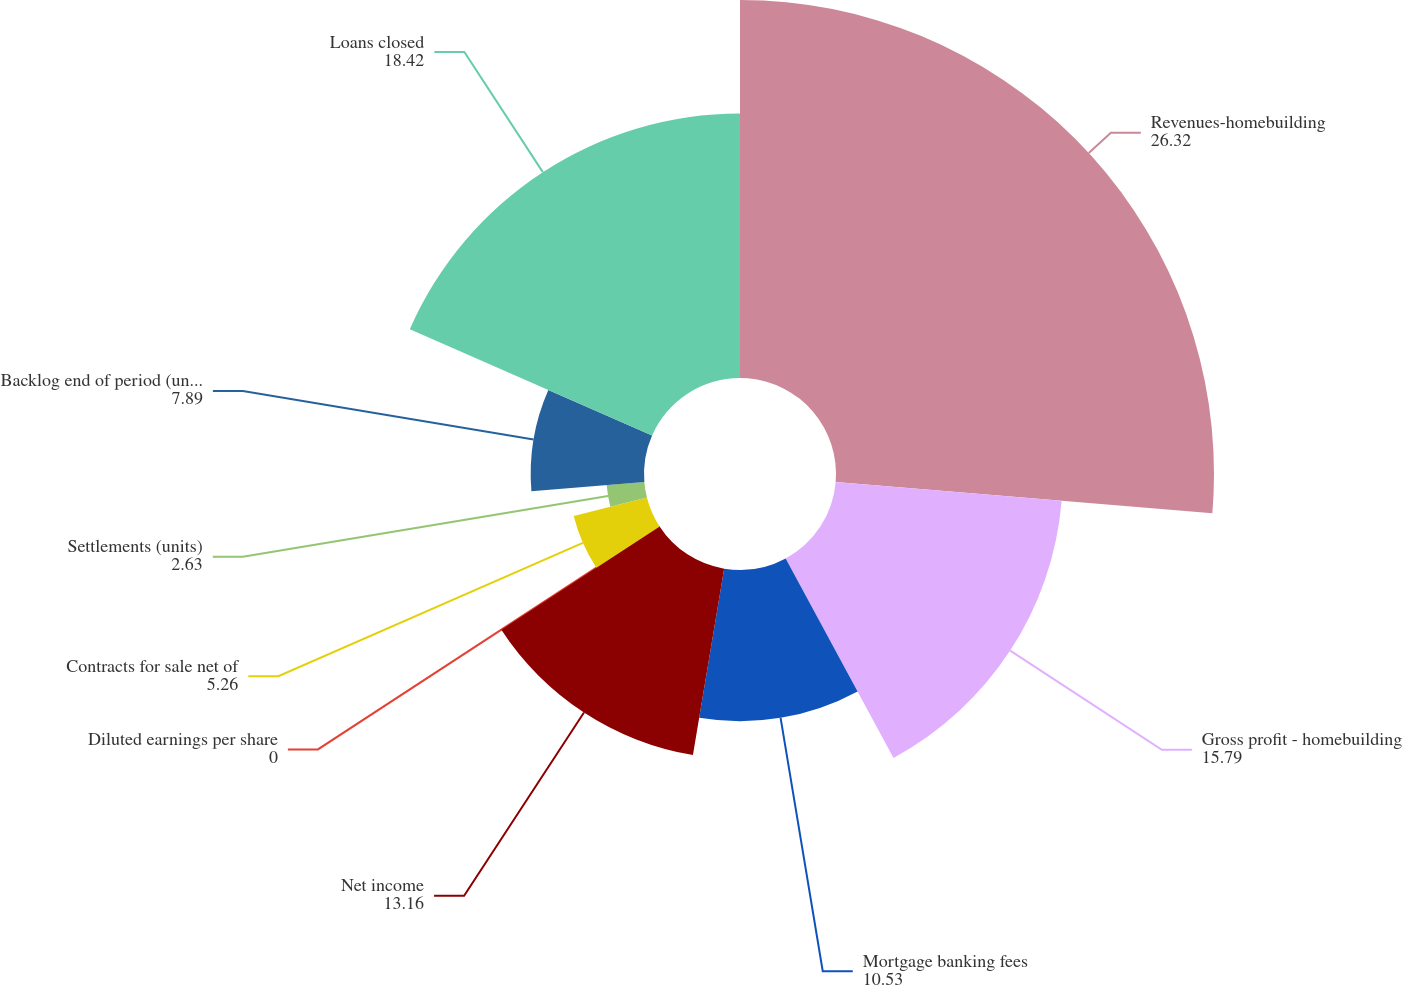Convert chart. <chart><loc_0><loc_0><loc_500><loc_500><pie_chart><fcel>Revenues-homebuilding<fcel>Gross profit - homebuilding<fcel>Mortgage banking fees<fcel>Net income<fcel>Diluted earnings per share<fcel>Contracts for sale net of<fcel>Settlements (units)<fcel>Backlog end of period (units)<fcel>Loans closed<nl><fcel>26.32%<fcel>15.79%<fcel>10.53%<fcel>13.16%<fcel>0.0%<fcel>5.26%<fcel>2.63%<fcel>7.89%<fcel>18.42%<nl></chart> 